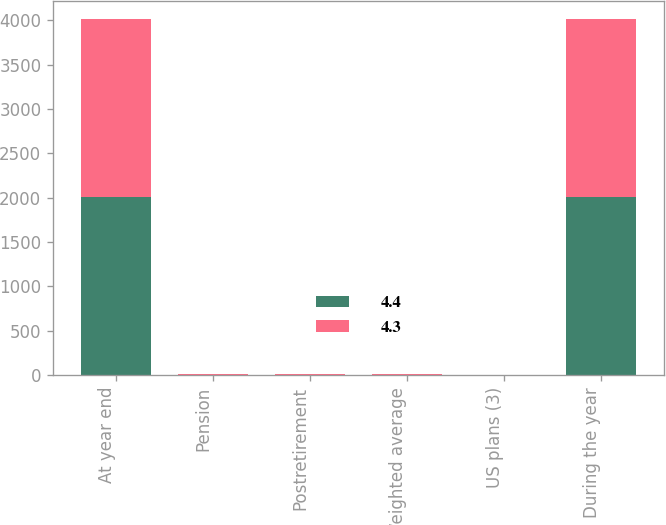<chart> <loc_0><loc_0><loc_500><loc_500><stacked_bar_chart><ecel><fcel>At year end<fcel>Pension<fcel>Postretirement<fcel>Weighted average<fcel>US plans (3)<fcel>During the year<nl><fcel>4.4<fcel>2008<fcel>6.1<fcel>6<fcel>6.6<fcel>3<fcel>2008<nl><fcel>4.3<fcel>2007<fcel>6.2<fcel>6<fcel>6.2<fcel>3<fcel>2007<nl></chart> 